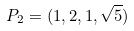<formula> <loc_0><loc_0><loc_500><loc_500>P _ { 2 } = ( 1 , 2 , 1 , \sqrt { 5 } )</formula> 